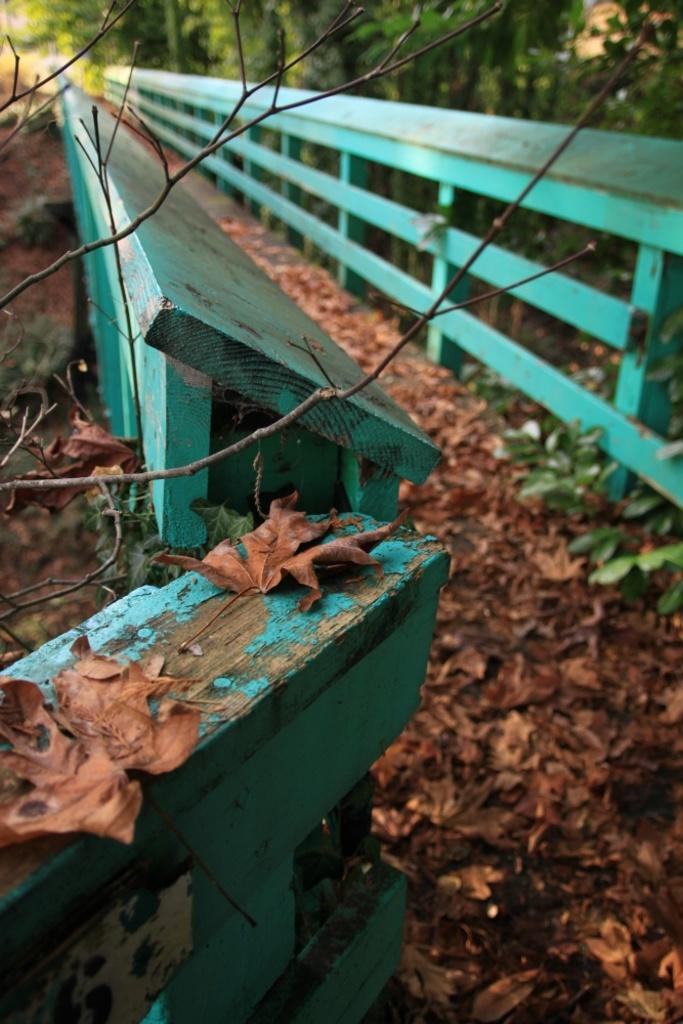Where was the image taken? The image was clicked outside. What is located in the front of the image? There is a wooden bench in the front of the image. What can be seen at the bottom of the image? Brown leaves are present at the bottom of the image. What is visible in the background of the image? There are trees in the background of the image. What type of government is depicted in the image? There is no depiction of a government in the image; it features a wooden bench, brown leaves, and trees. Can you see a squirrel climbing on the trees in the background? There is no squirrel visible in the image; only trees are present in the background. 